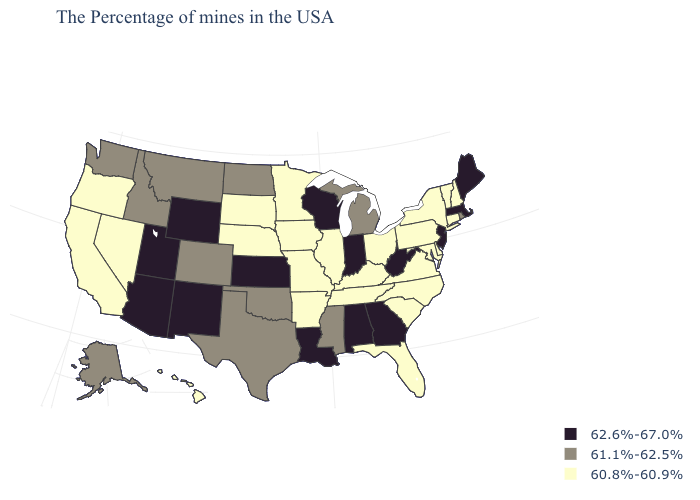Does Indiana have the highest value in the MidWest?
Keep it brief. Yes. Among the states that border Massachusetts , does Rhode Island have the lowest value?
Short answer required. No. Does Indiana have the same value as New Jersey?
Write a very short answer. Yes. What is the highest value in states that border Texas?
Short answer required. 62.6%-67.0%. Does the map have missing data?
Give a very brief answer. No. Name the states that have a value in the range 61.1%-62.5%?
Answer briefly. Rhode Island, Michigan, Mississippi, Oklahoma, Texas, North Dakota, Colorado, Montana, Idaho, Washington, Alaska. What is the highest value in the South ?
Short answer required. 62.6%-67.0%. What is the value of Maine?
Answer briefly. 62.6%-67.0%. What is the highest value in the Northeast ?
Be succinct. 62.6%-67.0%. Does Mississippi have a higher value than Virginia?
Short answer required. Yes. What is the value of New Jersey?
Quick response, please. 62.6%-67.0%. Which states have the lowest value in the USA?
Concise answer only. New Hampshire, Vermont, Connecticut, New York, Delaware, Maryland, Pennsylvania, Virginia, North Carolina, South Carolina, Ohio, Florida, Kentucky, Tennessee, Illinois, Missouri, Arkansas, Minnesota, Iowa, Nebraska, South Dakota, Nevada, California, Oregon, Hawaii. 